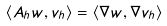<formula> <loc_0><loc_0><loc_500><loc_500>\langle A _ { h } w , v _ { h } \rangle = \langle \nabla w , \nabla v _ { h } \rangle</formula> 